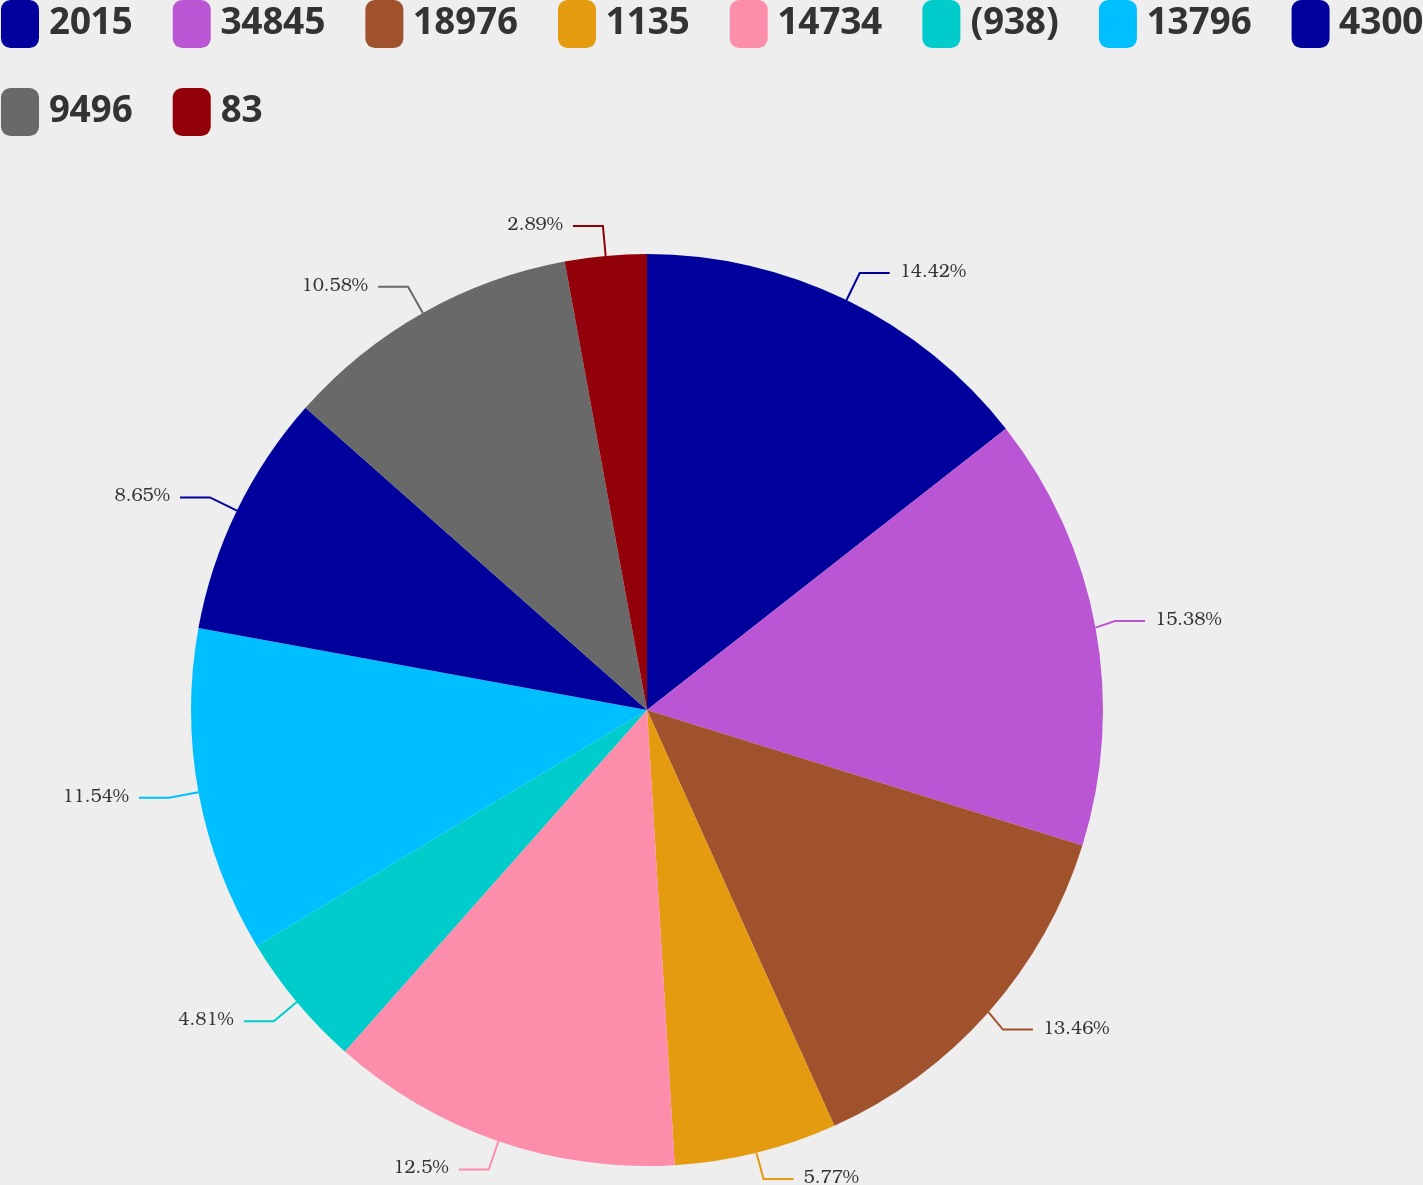Convert chart. <chart><loc_0><loc_0><loc_500><loc_500><pie_chart><fcel>2015<fcel>34845<fcel>18976<fcel>1135<fcel>14734<fcel>(938)<fcel>13796<fcel>4300<fcel>9496<fcel>83<nl><fcel>14.42%<fcel>15.38%<fcel>13.46%<fcel>5.77%<fcel>12.5%<fcel>4.81%<fcel>11.54%<fcel>8.65%<fcel>10.58%<fcel>2.89%<nl></chart> 